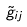Convert formula to latex. <formula><loc_0><loc_0><loc_500><loc_500>\tilde { g } _ { i j }</formula> 